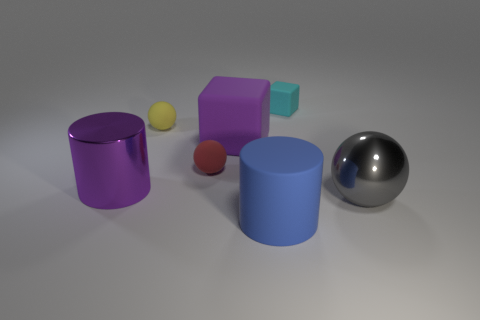There is a purple shiny thing that is the same shape as the blue object; what is its size?
Provide a short and direct response. Large. Do the matte block to the left of the blue rubber thing and the big metallic thing to the left of the small cyan matte object have the same color?
Your answer should be compact. Yes. Is the material of the cube left of the tiny cube the same as the purple cylinder?
Keep it short and to the point. No. What shape is the rubber object that is in front of the yellow object and to the right of the purple matte thing?
Keep it short and to the point. Cylinder. Are there any tiny things that are on the left side of the big cylinder on the right side of the yellow ball?
Give a very brief answer. Yes. What number of other objects are there of the same material as the small yellow sphere?
Your answer should be very brief. 4. Is the shape of the rubber object right of the blue rubber thing the same as the big purple object right of the small yellow thing?
Offer a very short reply. Yes. Do the big blue cylinder and the gray object have the same material?
Your answer should be compact. No. What size is the cylinder that is in front of the gray metallic sphere on the right side of the metal thing that is on the left side of the small rubber cube?
Provide a short and direct response. Large. How many other things are the same color as the rubber cylinder?
Your response must be concise. 0. 